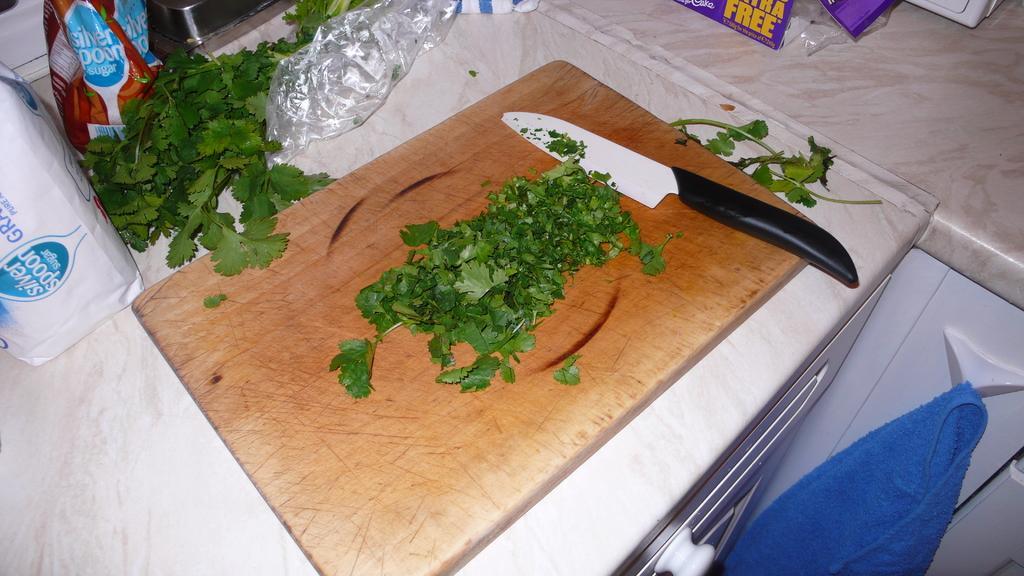Could you give a brief overview of what you see in this image? In the image we can see there is a vegetable cutting pad on which there are coriander leaves which are cut into pieces. Beside there is a knife and there are coriander leaves. There is a plastic cover and there are packets kept on the table. There is a cloth which is kept on the wall clip. 